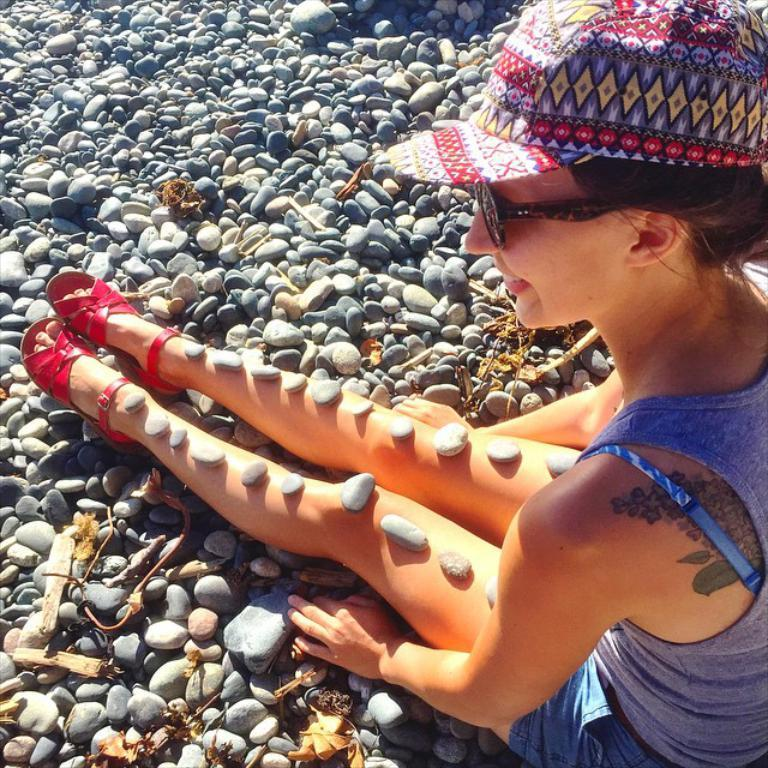What is the position of the woman in the image? The woman is sitting on the right side of the image. What is on the woman in the image? There are stones on the woman. What type of stones are present in the image? There are small stones at the bottom of the image. What type of comfort does the squirrel provide for the woman in the image? There is no squirrel present in the image, so it cannot provide any comfort for the woman. 